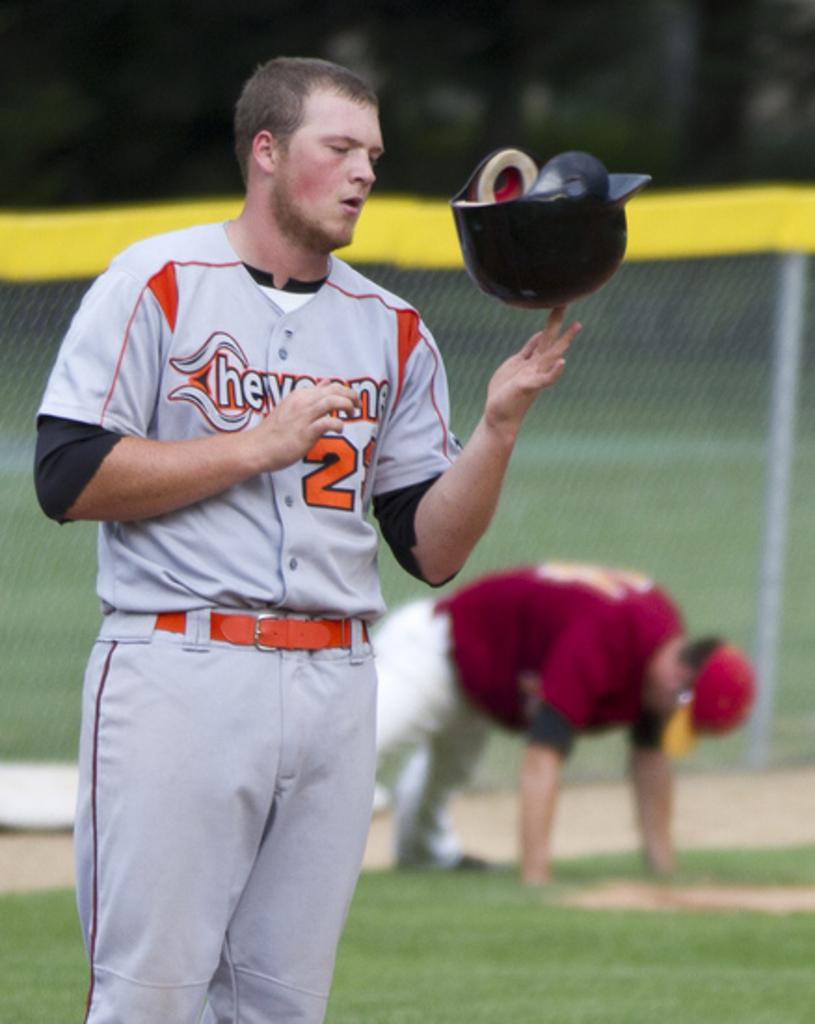What is the first number of this player?
Offer a terse response. 2. 